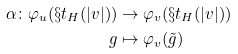Convert formula to latex. <formula><loc_0><loc_0><loc_500><loc_500>\alpha \colon \varphi _ { u } ( \S t _ { H } ( | v | ) ) & \rightarrow \varphi _ { v } ( \S t _ { H } ( | v | ) ) \\ g & \mapsto \varphi _ { v } ( \tilde { g } )</formula> 